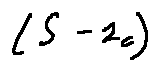<formula> <loc_0><loc_0><loc_500><loc_500>( S - l _ { C } )</formula> 